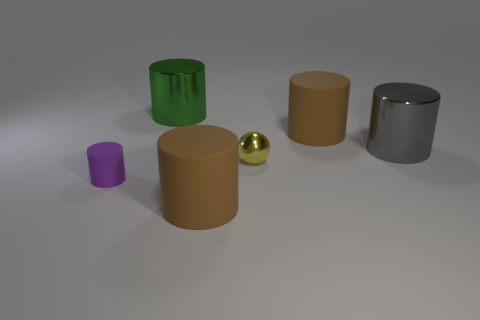What is the shape of the green thing?
Offer a very short reply. Cylinder. What is the shape of the big brown matte thing left of the brown matte cylinder that is behind the large gray object?
Provide a short and direct response. Cylinder. What number of other objects are there of the same shape as the green metal thing?
Make the answer very short. 4. How big is the metal thing that is on the right side of the large matte cylinder right of the metallic sphere?
Your answer should be very brief. Large. Is there a tiny metal sphere?
Your response must be concise. Yes. There is a big brown matte cylinder that is in front of the small sphere; what number of tiny yellow balls are on the left side of it?
Provide a short and direct response. 0. There is a tiny object to the right of the green metal object; what shape is it?
Offer a terse response. Sphere. There is a cylinder that is left of the large shiny cylinder that is left of the rubber thing that is in front of the small rubber cylinder; what is it made of?
Your answer should be compact. Rubber. How many other objects are there of the same size as the purple matte cylinder?
Keep it short and to the point. 1. There is a tiny object that is the same shape as the large gray thing; what is it made of?
Provide a succinct answer. Rubber. 